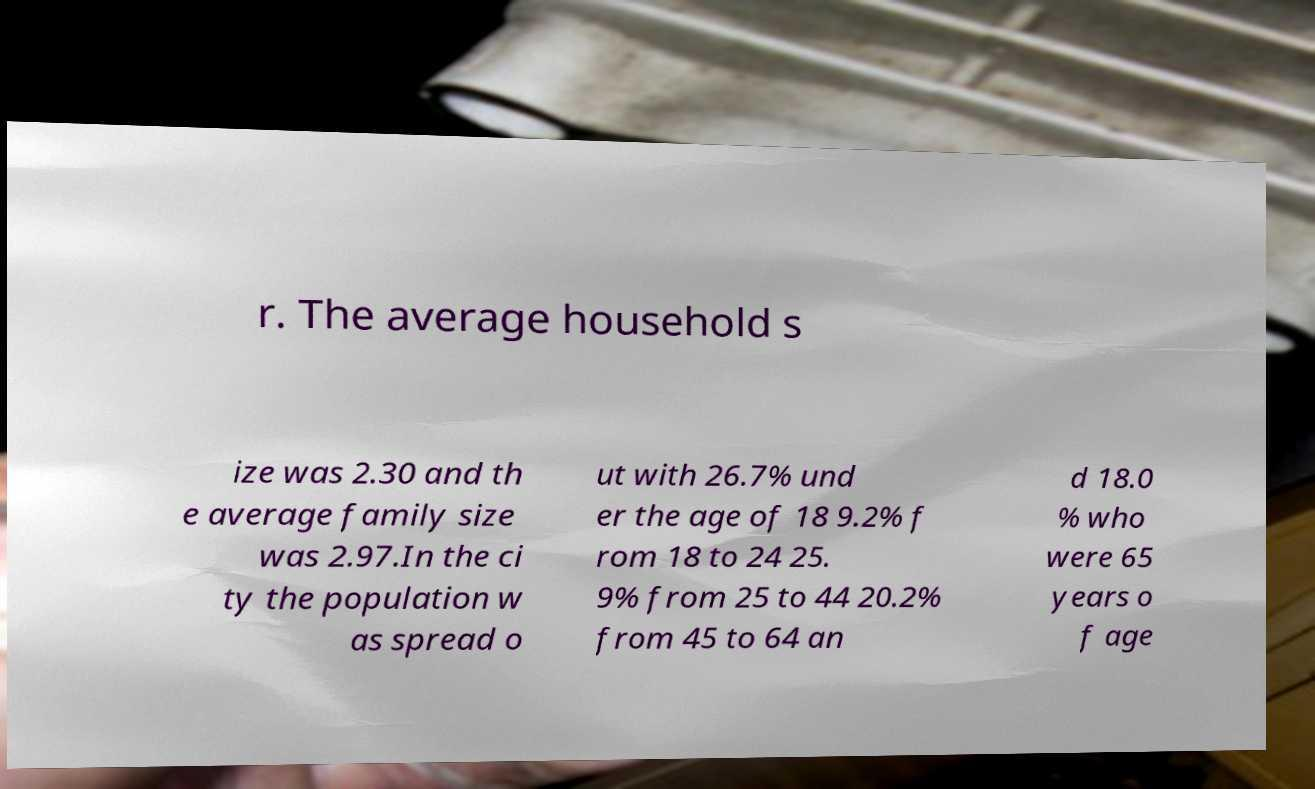Could you assist in decoding the text presented in this image and type it out clearly? r. The average household s ize was 2.30 and th e average family size was 2.97.In the ci ty the population w as spread o ut with 26.7% und er the age of 18 9.2% f rom 18 to 24 25. 9% from 25 to 44 20.2% from 45 to 64 an d 18.0 % who were 65 years o f age 